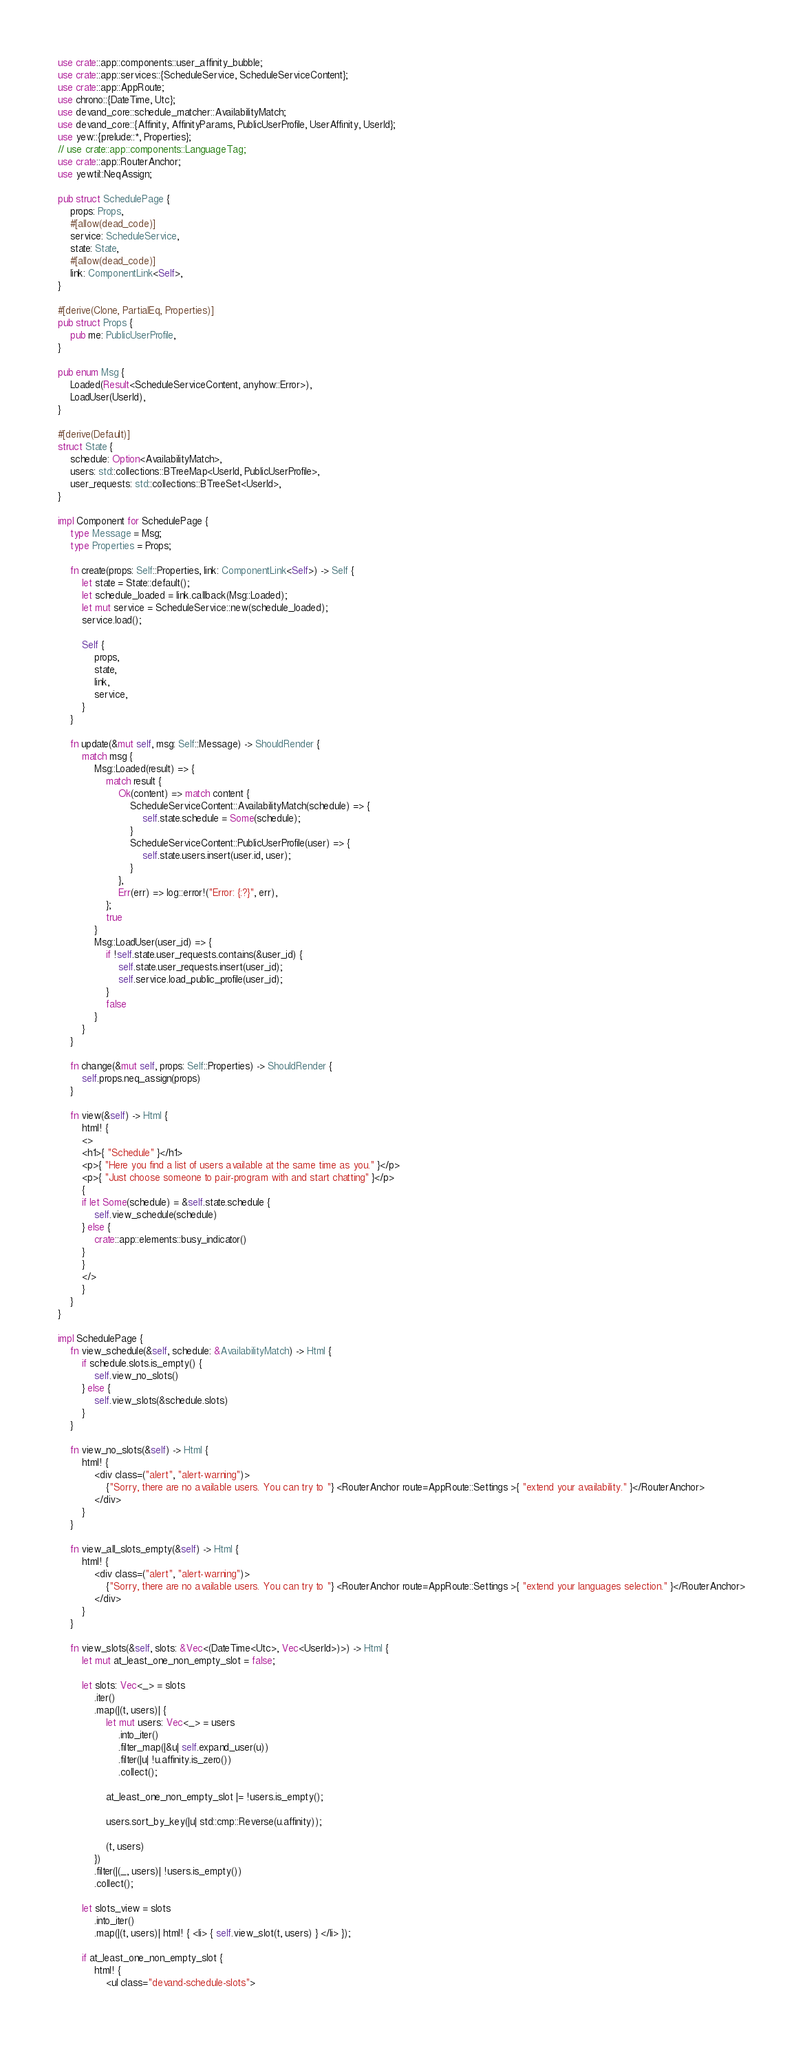<code> <loc_0><loc_0><loc_500><loc_500><_Rust_>use crate::app::components::user_affinity_bubble;
use crate::app::services::{ScheduleService, ScheduleServiceContent};
use crate::app::AppRoute;
use chrono::{DateTime, Utc};
use devand_core::schedule_matcher::AvailabilityMatch;
use devand_core::{Affinity, AffinityParams, PublicUserProfile, UserAffinity, UserId};
use yew::{prelude::*, Properties};
// use crate::app::components::LanguageTag;
use crate::app::RouterAnchor;
use yewtil::NeqAssign;

pub struct SchedulePage {
    props: Props,
    #[allow(dead_code)]
    service: ScheduleService,
    state: State,
    #[allow(dead_code)]
    link: ComponentLink<Self>,
}

#[derive(Clone, PartialEq, Properties)]
pub struct Props {
    pub me: PublicUserProfile,
}

pub enum Msg {
    Loaded(Result<ScheduleServiceContent, anyhow::Error>),
    LoadUser(UserId),
}

#[derive(Default)]
struct State {
    schedule: Option<AvailabilityMatch>,
    users: std::collections::BTreeMap<UserId, PublicUserProfile>,
    user_requests: std::collections::BTreeSet<UserId>,
}

impl Component for SchedulePage {
    type Message = Msg;
    type Properties = Props;

    fn create(props: Self::Properties, link: ComponentLink<Self>) -> Self {
        let state = State::default();
        let schedule_loaded = link.callback(Msg::Loaded);
        let mut service = ScheduleService::new(schedule_loaded);
        service.load();

        Self {
            props,
            state,
            link,
            service,
        }
    }

    fn update(&mut self, msg: Self::Message) -> ShouldRender {
        match msg {
            Msg::Loaded(result) => {
                match result {
                    Ok(content) => match content {
                        ScheduleServiceContent::AvailabilityMatch(schedule) => {
                            self.state.schedule = Some(schedule);
                        }
                        ScheduleServiceContent::PublicUserProfile(user) => {
                            self.state.users.insert(user.id, user);
                        }
                    },
                    Err(err) => log::error!("Error: {:?}", err),
                };
                true
            }
            Msg::LoadUser(user_id) => {
                if !self.state.user_requests.contains(&user_id) {
                    self.state.user_requests.insert(user_id);
                    self.service.load_public_profile(user_id);
                }
                false
            }
        }
    }

    fn change(&mut self, props: Self::Properties) -> ShouldRender {
        self.props.neq_assign(props)
    }

    fn view(&self) -> Html {
        html! {
        <>
        <h1>{ "Schedule" }</h1>
        <p>{ "Here you find a list of users available at the same time as you." }</p>
        <p>{ "Just choose someone to pair-program with and start chatting" }</p>
        {
        if let Some(schedule) = &self.state.schedule {
            self.view_schedule(schedule)
        } else {
            crate::app::elements::busy_indicator()
        }
        }
        </>
        }
    }
}

impl SchedulePage {
    fn view_schedule(&self, schedule: &AvailabilityMatch) -> Html {
        if schedule.slots.is_empty() {
            self.view_no_slots()
        } else {
            self.view_slots(&schedule.slots)
        }
    }

    fn view_no_slots(&self) -> Html {
        html! {
            <div class=("alert", "alert-warning")>
                {"Sorry, there are no available users. You can try to "} <RouterAnchor route=AppRoute::Settings >{ "extend your availability." }</RouterAnchor>
            </div>
        }
    }

    fn view_all_slots_empty(&self) -> Html {
        html! {
            <div class=("alert", "alert-warning")>
                {"Sorry, there are no available users. You can try to "} <RouterAnchor route=AppRoute::Settings >{ "extend your languages selection." }</RouterAnchor>
            </div>
        }
    }

    fn view_slots(&self, slots: &Vec<(DateTime<Utc>, Vec<UserId>)>) -> Html {
        let mut at_least_one_non_empty_slot = false;

        let slots: Vec<_> = slots
            .iter()
            .map(|(t, users)| {
                let mut users: Vec<_> = users
                    .into_iter()
                    .filter_map(|&u| self.expand_user(u))
                    .filter(|u| !u.affinity.is_zero())
                    .collect();

                at_least_one_non_empty_slot |= !users.is_empty();

                users.sort_by_key(|u| std::cmp::Reverse(u.affinity));

                (t, users)
            })
            .filter(|(_, users)| !users.is_empty())
            .collect();

        let slots_view = slots
            .into_iter()
            .map(|(t, users)| html! { <li> { self.view_slot(t, users) } </li> });

        if at_least_one_non_empty_slot {
            html! {
                <ul class="devand-schedule-slots"></code> 